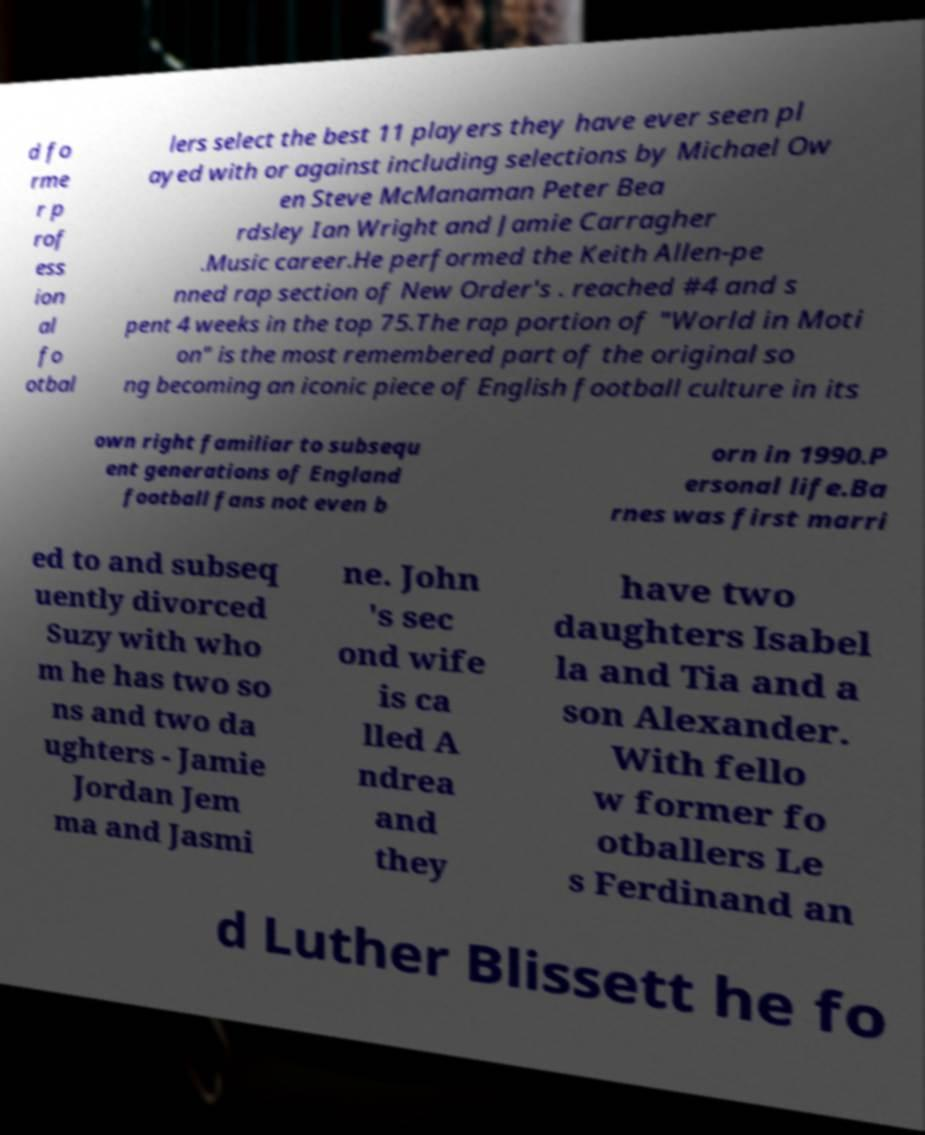Can you accurately transcribe the text from the provided image for me? d fo rme r p rof ess ion al fo otbal lers select the best 11 players they have ever seen pl ayed with or against including selections by Michael Ow en Steve McManaman Peter Bea rdsley Ian Wright and Jamie Carragher .Music career.He performed the Keith Allen-pe nned rap section of New Order's . reached #4 and s pent 4 weeks in the top 75.The rap portion of "World in Moti on" is the most remembered part of the original so ng becoming an iconic piece of English football culture in its own right familiar to subsequ ent generations of England football fans not even b orn in 1990.P ersonal life.Ba rnes was first marri ed to and subseq uently divorced Suzy with who m he has two so ns and two da ughters - Jamie Jordan Jem ma and Jasmi ne. John 's sec ond wife is ca lled A ndrea and they have two daughters Isabel la and Tia and a son Alexander. With fello w former fo otballers Le s Ferdinand an d Luther Blissett he fo 